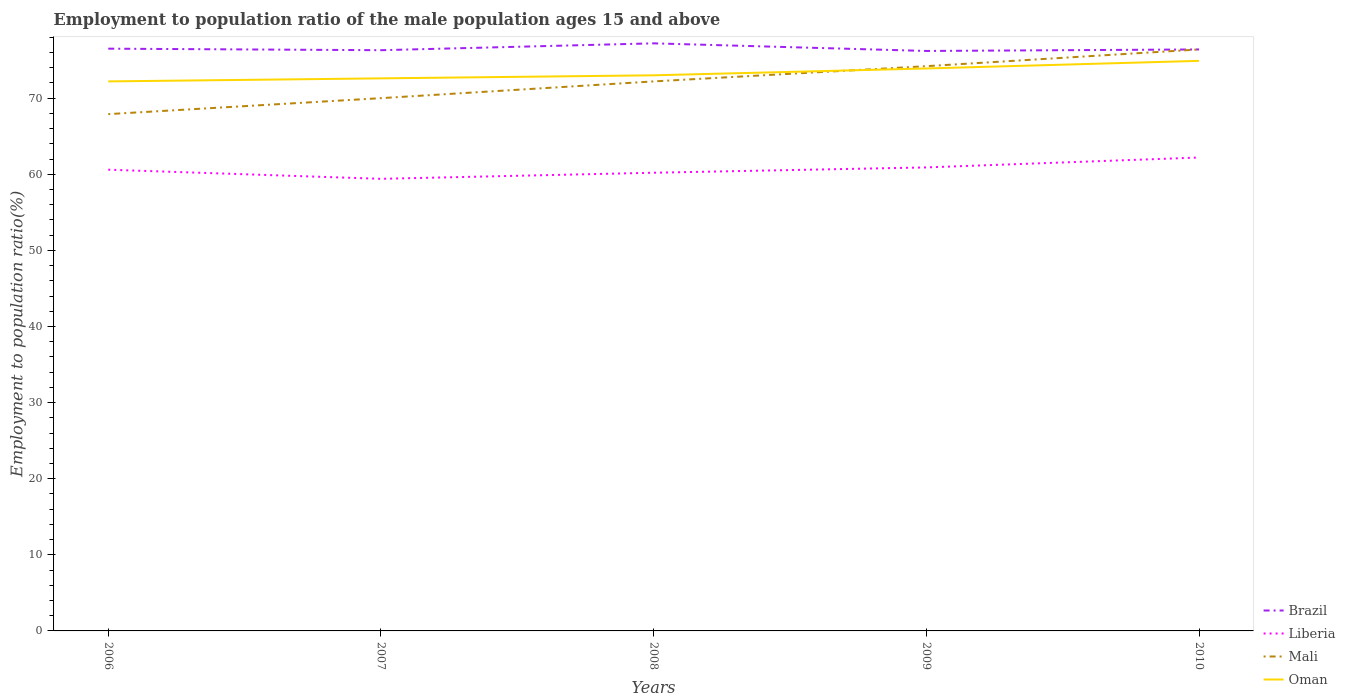How many different coloured lines are there?
Your answer should be compact. 4. Is the number of lines equal to the number of legend labels?
Provide a short and direct response. Yes. Across all years, what is the maximum employment to population ratio in Mali?
Give a very brief answer. 67.9. What is the total employment to population ratio in Oman in the graph?
Offer a very short reply. -1.9. What is the difference between the highest and the second highest employment to population ratio in Mali?
Give a very brief answer. 8.5. What is the difference between the highest and the lowest employment to population ratio in Brazil?
Your response must be concise. 1. How many lines are there?
Offer a very short reply. 4. How many years are there in the graph?
Your response must be concise. 5. What is the difference between two consecutive major ticks on the Y-axis?
Make the answer very short. 10. Are the values on the major ticks of Y-axis written in scientific E-notation?
Provide a short and direct response. No. Does the graph contain grids?
Provide a short and direct response. No. How are the legend labels stacked?
Offer a terse response. Vertical. What is the title of the graph?
Make the answer very short. Employment to population ratio of the male population ages 15 and above. What is the label or title of the X-axis?
Keep it short and to the point. Years. What is the Employment to population ratio(%) of Brazil in 2006?
Your answer should be very brief. 76.5. What is the Employment to population ratio(%) in Liberia in 2006?
Keep it short and to the point. 60.6. What is the Employment to population ratio(%) of Mali in 2006?
Your answer should be compact. 67.9. What is the Employment to population ratio(%) of Oman in 2006?
Offer a terse response. 72.2. What is the Employment to population ratio(%) in Brazil in 2007?
Give a very brief answer. 76.3. What is the Employment to population ratio(%) in Liberia in 2007?
Provide a short and direct response. 59.4. What is the Employment to population ratio(%) in Mali in 2007?
Provide a succinct answer. 70. What is the Employment to population ratio(%) of Oman in 2007?
Your answer should be compact. 72.6. What is the Employment to population ratio(%) of Brazil in 2008?
Your answer should be very brief. 77.2. What is the Employment to population ratio(%) of Liberia in 2008?
Ensure brevity in your answer.  60.2. What is the Employment to population ratio(%) in Mali in 2008?
Keep it short and to the point. 72.2. What is the Employment to population ratio(%) in Brazil in 2009?
Your answer should be very brief. 76.2. What is the Employment to population ratio(%) in Liberia in 2009?
Make the answer very short. 60.9. What is the Employment to population ratio(%) of Mali in 2009?
Make the answer very short. 74.2. What is the Employment to population ratio(%) in Oman in 2009?
Provide a short and direct response. 73.9. What is the Employment to population ratio(%) in Brazil in 2010?
Keep it short and to the point. 76.4. What is the Employment to population ratio(%) in Liberia in 2010?
Your answer should be very brief. 62.2. What is the Employment to population ratio(%) of Mali in 2010?
Ensure brevity in your answer.  76.4. What is the Employment to population ratio(%) in Oman in 2010?
Offer a terse response. 74.9. Across all years, what is the maximum Employment to population ratio(%) in Brazil?
Keep it short and to the point. 77.2. Across all years, what is the maximum Employment to population ratio(%) in Liberia?
Keep it short and to the point. 62.2. Across all years, what is the maximum Employment to population ratio(%) in Mali?
Ensure brevity in your answer.  76.4. Across all years, what is the maximum Employment to population ratio(%) of Oman?
Your answer should be very brief. 74.9. Across all years, what is the minimum Employment to population ratio(%) in Brazil?
Your answer should be compact. 76.2. Across all years, what is the minimum Employment to population ratio(%) in Liberia?
Your answer should be compact. 59.4. Across all years, what is the minimum Employment to population ratio(%) in Mali?
Provide a short and direct response. 67.9. Across all years, what is the minimum Employment to population ratio(%) in Oman?
Your answer should be very brief. 72.2. What is the total Employment to population ratio(%) of Brazil in the graph?
Your answer should be very brief. 382.6. What is the total Employment to population ratio(%) of Liberia in the graph?
Give a very brief answer. 303.3. What is the total Employment to population ratio(%) in Mali in the graph?
Keep it short and to the point. 360.7. What is the total Employment to population ratio(%) of Oman in the graph?
Your answer should be very brief. 366.6. What is the difference between the Employment to population ratio(%) of Brazil in 2006 and that in 2007?
Ensure brevity in your answer.  0.2. What is the difference between the Employment to population ratio(%) in Liberia in 2006 and that in 2007?
Offer a terse response. 1.2. What is the difference between the Employment to population ratio(%) in Mali in 2006 and that in 2007?
Give a very brief answer. -2.1. What is the difference between the Employment to population ratio(%) in Liberia in 2006 and that in 2008?
Keep it short and to the point. 0.4. What is the difference between the Employment to population ratio(%) of Liberia in 2006 and that in 2009?
Ensure brevity in your answer.  -0.3. What is the difference between the Employment to population ratio(%) of Mali in 2006 and that in 2009?
Provide a short and direct response. -6.3. What is the difference between the Employment to population ratio(%) of Oman in 2006 and that in 2009?
Your response must be concise. -1.7. What is the difference between the Employment to population ratio(%) in Liberia in 2007 and that in 2008?
Your answer should be very brief. -0.8. What is the difference between the Employment to population ratio(%) of Mali in 2007 and that in 2008?
Provide a succinct answer. -2.2. What is the difference between the Employment to population ratio(%) in Oman in 2007 and that in 2008?
Your answer should be compact. -0.4. What is the difference between the Employment to population ratio(%) of Brazil in 2007 and that in 2009?
Keep it short and to the point. 0.1. What is the difference between the Employment to population ratio(%) in Oman in 2007 and that in 2009?
Your answer should be compact. -1.3. What is the difference between the Employment to population ratio(%) in Brazil in 2007 and that in 2010?
Provide a short and direct response. -0.1. What is the difference between the Employment to population ratio(%) in Oman in 2007 and that in 2010?
Your answer should be compact. -2.3. What is the difference between the Employment to population ratio(%) in Brazil in 2008 and that in 2010?
Give a very brief answer. 0.8. What is the difference between the Employment to population ratio(%) in Liberia in 2008 and that in 2010?
Make the answer very short. -2. What is the difference between the Employment to population ratio(%) of Mali in 2008 and that in 2010?
Your answer should be compact. -4.2. What is the difference between the Employment to population ratio(%) in Oman in 2008 and that in 2010?
Provide a succinct answer. -1.9. What is the difference between the Employment to population ratio(%) in Brazil in 2006 and the Employment to population ratio(%) in Oman in 2007?
Provide a succinct answer. 3.9. What is the difference between the Employment to population ratio(%) in Liberia in 2006 and the Employment to population ratio(%) in Mali in 2007?
Give a very brief answer. -9.4. What is the difference between the Employment to population ratio(%) of Liberia in 2006 and the Employment to population ratio(%) of Oman in 2007?
Make the answer very short. -12. What is the difference between the Employment to population ratio(%) of Mali in 2006 and the Employment to population ratio(%) of Oman in 2007?
Your response must be concise. -4.7. What is the difference between the Employment to population ratio(%) in Brazil in 2006 and the Employment to population ratio(%) in Liberia in 2008?
Ensure brevity in your answer.  16.3. What is the difference between the Employment to population ratio(%) in Brazil in 2006 and the Employment to population ratio(%) in Mali in 2008?
Offer a very short reply. 4.3. What is the difference between the Employment to population ratio(%) of Brazil in 2006 and the Employment to population ratio(%) of Oman in 2008?
Your answer should be compact. 3.5. What is the difference between the Employment to population ratio(%) of Liberia in 2006 and the Employment to population ratio(%) of Mali in 2008?
Provide a succinct answer. -11.6. What is the difference between the Employment to population ratio(%) of Mali in 2006 and the Employment to population ratio(%) of Oman in 2008?
Keep it short and to the point. -5.1. What is the difference between the Employment to population ratio(%) of Brazil in 2006 and the Employment to population ratio(%) of Mali in 2009?
Your answer should be very brief. 2.3. What is the difference between the Employment to population ratio(%) of Liberia in 2006 and the Employment to population ratio(%) of Mali in 2009?
Ensure brevity in your answer.  -13.6. What is the difference between the Employment to population ratio(%) in Liberia in 2006 and the Employment to population ratio(%) in Oman in 2009?
Make the answer very short. -13.3. What is the difference between the Employment to population ratio(%) of Mali in 2006 and the Employment to population ratio(%) of Oman in 2009?
Ensure brevity in your answer.  -6. What is the difference between the Employment to population ratio(%) in Liberia in 2006 and the Employment to population ratio(%) in Mali in 2010?
Provide a short and direct response. -15.8. What is the difference between the Employment to population ratio(%) of Liberia in 2006 and the Employment to population ratio(%) of Oman in 2010?
Provide a short and direct response. -14.3. What is the difference between the Employment to population ratio(%) in Brazil in 2007 and the Employment to population ratio(%) in Liberia in 2008?
Provide a short and direct response. 16.1. What is the difference between the Employment to population ratio(%) in Brazil in 2007 and the Employment to population ratio(%) in Oman in 2008?
Provide a short and direct response. 3.3. What is the difference between the Employment to population ratio(%) in Liberia in 2007 and the Employment to population ratio(%) in Oman in 2008?
Keep it short and to the point. -13.6. What is the difference between the Employment to population ratio(%) in Brazil in 2007 and the Employment to population ratio(%) in Liberia in 2009?
Make the answer very short. 15.4. What is the difference between the Employment to population ratio(%) of Liberia in 2007 and the Employment to population ratio(%) of Mali in 2009?
Offer a very short reply. -14.8. What is the difference between the Employment to population ratio(%) of Liberia in 2007 and the Employment to population ratio(%) of Oman in 2009?
Your response must be concise. -14.5. What is the difference between the Employment to population ratio(%) in Mali in 2007 and the Employment to population ratio(%) in Oman in 2009?
Make the answer very short. -3.9. What is the difference between the Employment to population ratio(%) of Brazil in 2007 and the Employment to population ratio(%) of Liberia in 2010?
Make the answer very short. 14.1. What is the difference between the Employment to population ratio(%) in Liberia in 2007 and the Employment to population ratio(%) in Oman in 2010?
Your answer should be compact. -15.5. What is the difference between the Employment to population ratio(%) in Liberia in 2008 and the Employment to population ratio(%) in Mali in 2009?
Provide a succinct answer. -14. What is the difference between the Employment to population ratio(%) in Liberia in 2008 and the Employment to population ratio(%) in Oman in 2009?
Provide a succinct answer. -13.7. What is the difference between the Employment to population ratio(%) of Liberia in 2008 and the Employment to population ratio(%) of Mali in 2010?
Your answer should be compact. -16.2. What is the difference between the Employment to population ratio(%) in Liberia in 2008 and the Employment to population ratio(%) in Oman in 2010?
Ensure brevity in your answer.  -14.7. What is the difference between the Employment to population ratio(%) of Brazil in 2009 and the Employment to population ratio(%) of Liberia in 2010?
Your answer should be very brief. 14. What is the difference between the Employment to population ratio(%) in Liberia in 2009 and the Employment to population ratio(%) in Mali in 2010?
Ensure brevity in your answer.  -15.5. What is the difference between the Employment to population ratio(%) in Liberia in 2009 and the Employment to population ratio(%) in Oman in 2010?
Ensure brevity in your answer.  -14. What is the difference between the Employment to population ratio(%) in Mali in 2009 and the Employment to population ratio(%) in Oman in 2010?
Keep it short and to the point. -0.7. What is the average Employment to population ratio(%) in Brazil per year?
Provide a succinct answer. 76.52. What is the average Employment to population ratio(%) in Liberia per year?
Your answer should be compact. 60.66. What is the average Employment to population ratio(%) of Mali per year?
Make the answer very short. 72.14. What is the average Employment to population ratio(%) of Oman per year?
Your answer should be very brief. 73.32. In the year 2006, what is the difference between the Employment to population ratio(%) in Brazil and Employment to population ratio(%) in Liberia?
Your answer should be very brief. 15.9. In the year 2006, what is the difference between the Employment to population ratio(%) of Liberia and Employment to population ratio(%) of Oman?
Ensure brevity in your answer.  -11.6. In the year 2006, what is the difference between the Employment to population ratio(%) in Mali and Employment to population ratio(%) in Oman?
Offer a very short reply. -4.3. In the year 2007, what is the difference between the Employment to population ratio(%) of Brazil and Employment to population ratio(%) of Liberia?
Offer a very short reply. 16.9. In the year 2007, what is the difference between the Employment to population ratio(%) of Brazil and Employment to population ratio(%) of Oman?
Provide a short and direct response. 3.7. In the year 2007, what is the difference between the Employment to population ratio(%) in Liberia and Employment to population ratio(%) in Mali?
Your response must be concise. -10.6. In the year 2007, what is the difference between the Employment to population ratio(%) of Mali and Employment to population ratio(%) of Oman?
Offer a very short reply. -2.6. In the year 2008, what is the difference between the Employment to population ratio(%) in Brazil and Employment to population ratio(%) in Oman?
Provide a short and direct response. 4.2. In the year 2008, what is the difference between the Employment to population ratio(%) of Liberia and Employment to population ratio(%) of Mali?
Provide a succinct answer. -12. In the year 2008, what is the difference between the Employment to population ratio(%) of Liberia and Employment to population ratio(%) of Oman?
Your response must be concise. -12.8. In the year 2009, what is the difference between the Employment to population ratio(%) of Brazil and Employment to population ratio(%) of Mali?
Offer a very short reply. 2. In the year 2009, what is the difference between the Employment to population ratio(%) of Brazil and Employment to population ratio(%) of Oman?
Offer a terse response. 2.3. In the year 2009, what is the difference between the Employment to population ratio(%) of Liberia and Employment to population ratio(%) of Mali?
Your answer should be very brief. -13.3. In the year 2009, what is the difference between the Employment to population ratio(%) of Mali and Employment to population ratio(%) of Oman?
Give a very brief answer. 0.3. In the year 2010, what is the difference between the Employment to population ratio(%) in Brazil and Employment to population ratio(%) in Oman?
Make the answer very short. 1.5. In the year 2010, what is the difference between the Employment to population ratio(%) in Mali and Employment to population ratio(%) in Oman?
Your answer should be very brief. 1.5. What is the ratio of the Employment to population ratio(%) of Liberia in 2006 to that in 2007?
Make the answer very short. 1.02. What is the ratio of the Employment to population ratio(%) in Brazil in 2006 to that in 2008?
Give a very brief answer. 0.99. What is the ratio of the Employment to population ratio(%) of Liberia in 2006 to that in 2008?
Give a very brief answer. 1.01. What is the ratio of the Employment to population ratio(%) in Mali in 2006 to that in 2008?
Keep it short and to the point. 0.94. What is the ratio of the Employment to population ratio(%) in Brazil in 2006 to that in 2009?
Provide a succinct answer. 1. What is the ratio of the Employment to population ratio(%) of Mali in 2006 to that in 2009?
Your answer should be very brief. 0.92. What is the ratio of the Employment to population ratio(%) in Liberia in 2006 to that in 2010?
Your response must be concise. 0.97. What is the ratio of the Employment to population ratio(%) in Mali in 2006 to that in 2010?
Offer a terse response. 0.89. What is the ratio of the Employment to population ratio(%) of Brazil in 2007 to that in 2008?
Offer a terse response. 0.99. What is the ratio of the Employment to population ratio(%) of Liberia in 2007 to that in 2008?
Ensure brevity in your answer.  0.99. What is the ratio of the Employment to population ratio(%) in Mali in 2007 to that in 2008?
Offer a very short reply. 0.97. What is the ratio of the Employment to population ratio(%) of Oman in 2007 to that in 2008?
Provide a short and direct response. 0.99. What is the ratio of the Employment to population ratio(%) in Brazil in 2007 to that in 2009?
Your answer should be compact. 1. What is the ratio of the Employment to population ratio(%) of Liberia in 2007 to that in 2009?
Your response must be concise. 0.98. What is the ratio of the Employment to population ratio(%) in Mali in 2007 to that in 2009?
Ensure brevity in your answer.  0.94. What is the ratio of the Employment to population ratio(%) in Oman in 2007 to that in 2009?
Your response must be concise. 0.98. What is the ratio of the Employment to population ratio(%) of Brazil in 2007 to that in 2010?
Give a very brief answer. 1. What is the ratio of the Employment to population ratio(%) of Liberia in 2007 to that in 2010?
Offer a terse response. 0.95. What is the ratio of the Employment to population ratio(%) of Mali in 2007 to that in 2010?
Provide a succinct answer. 0.92. What is the ratio of the Employment to population ratio(%) in Oman in 2007 to that in 2010?
Your answer should be very brief. 0.97. What is the ratio of the Employment to population ratio(%) in Brazil in 2008 to that in 2009?
Your answer should be very brief. 1.01. What is the ratio of the Employment to population ratio(%) in Liberia in 2008 to that in 2009?
Provide a short and direct response. 0.99. What is the ratio of the Employment to population ratio(%) in Oman in 2008 to that in 2009?
Offer a very short reply. 0.99. What is the ratio of the Employment to population ratio(%) of Brazil in 2008 to that in 2010?
Give a very brief answer. 1.01. What is the ratio of the Employment to population ratio(%) of Liberia in 2008 to that in 2010?
Make the answer very short. 0.97. What is the ratio of the Employment to population ratio(%) of Mali in 2008 to that in 2010?
Offer a terse response. 0.94. What is the ratio of the Employment to population ratio(%) in Oman in 2008 to that in 2010?
Keep it short and to the point. 0.97. What is the ratio of the Employment to population ratio(%) in Brazil in 2009 to that in 2010?
Provide a succinct answer. 1. What is the ratio of the Employment to population ratio(%) of Liberia in 2009 to that in 2010?
Provide a short and direct response. 0.98. What is the ratio of the Employment to population ratio(%) of Mali in 2009 to that in 2010?
Provide a short and direct response. 0.97. What is the ratio of the Employment to population ratio(%) in Oman in 2009 to that in 2010?
Give a very brief answer. 0.99. What is the difference between the highest and the lowest Employment to population ratio(%) in Liberia?
Give a very brief answer. 2.8. What is the difference between the highest and the lowest Employment to population ratio(%) of Oman?
Give a very brief answer. 2.7. 